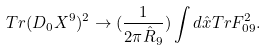Convert formula to latex. <formula><loc_0><loc_0><loc_500><loc_500>T r ( D _ { 0 } X ^ { 9 } ) ^ { 2 } \rightarrow ( \frac { 1 } { 2 \pi \hat { R } _ { 9 } } ) \int d \hat { x } T r F _ { 0 9 } ^ { 2 } .</formula> 